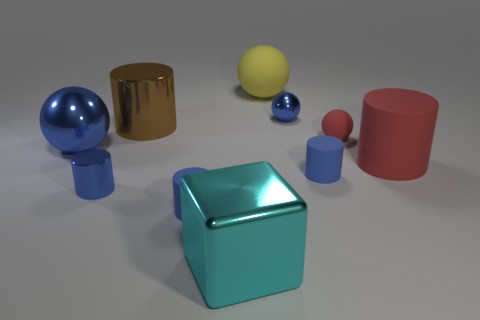Is the material of the large yellow sphere the same as the big sphere to the left of the large matte ball?
Keep it short and to the point. No. What is the size of the yellow object that is made of the same material as the tiny red ball?
Give a very brief answer. Large. There is a shiny cylinder in front of the large red cylinder; how big is it?
Provide a succinct answer. Small. How many red balls are the same size as the cyan metal object?
Make the answer very short. 0. There is another sphere that is the same color as the tiny metallic ball; what size is it?
Keep it short and to the point. Large. Are there any objects of the same color as the large metal cube?
Provide a short and direct response. No. There is another rubber cylinder that is the same size as the brown cylinder; what color is it?
Provide a succinct answer. Red. Do the large rubber cylinder and the shiny sphere that is on the right side of the cyan metal cube have the same color?
Ensure brevity in your answer.  No. The tiny shiny sphere is what color?
Make the answer very short. Blue. What material is the big cylinder that is right of the big cyan thing?
Make the answer very short. Rubber. 